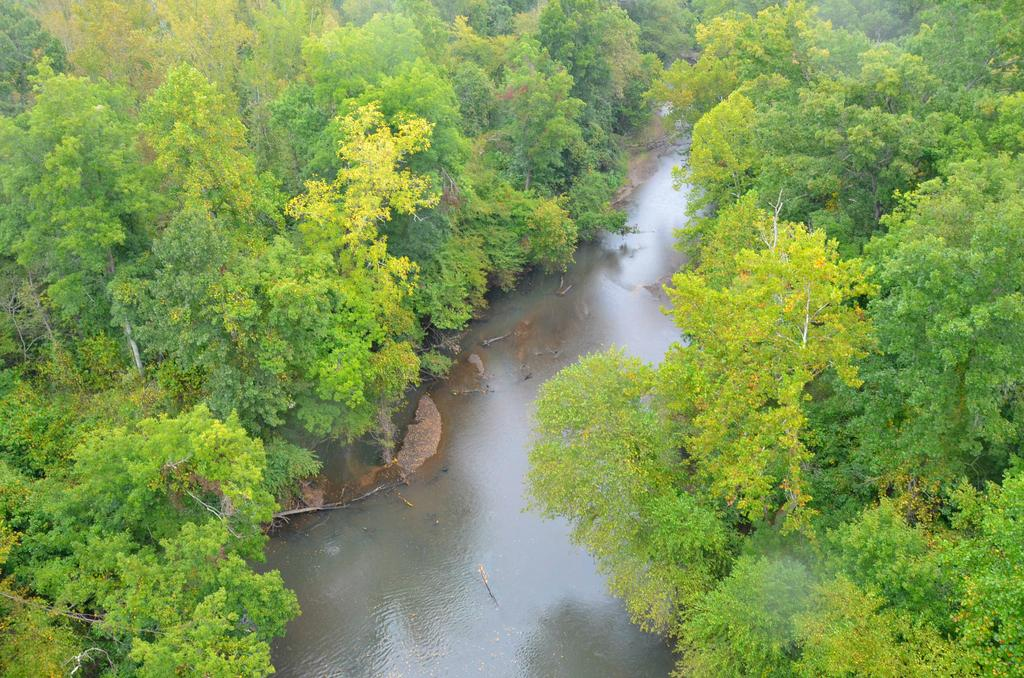What is visible in the image? There is water and trees visible in the image. Can you describe the water in the image? The water is visible, but its specific characteristics are not mentioned in the facts. What type of vegetation is present in the image? Trees are present in the image. What arithmetic problem is being solved by the trees in the image? There is no arithmetic problem being solved by the trees in the image, as trees are not capable of performing arithmetic. 